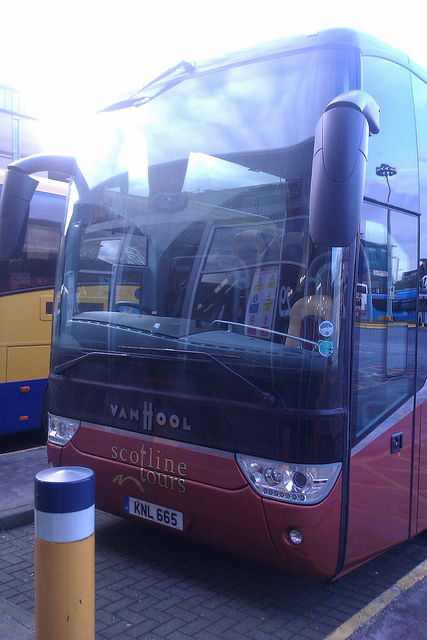Read and extract the text from this image. KNL 665 VAN HOOL tours scofline 